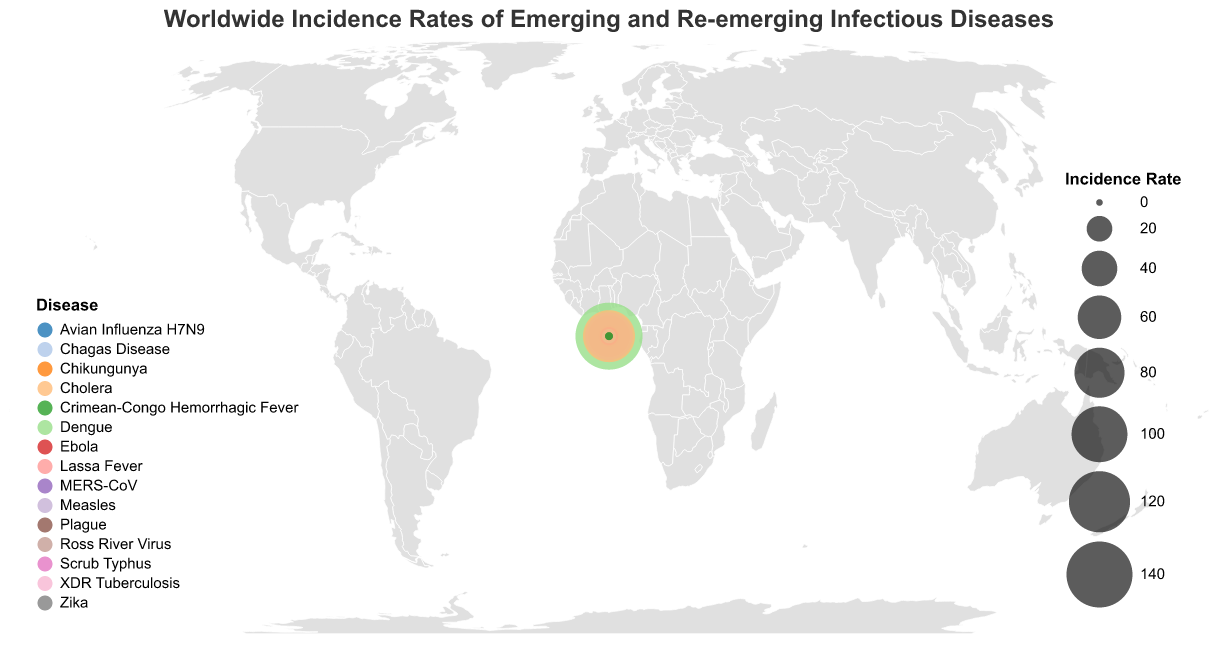What is the title of the figure? The title can be found directly at the top of the figure. It reads "Worldwide Incidence Rates of Emerging and Re-emerging Infectious Diseases."
Answer: Worldwide Incidence Rates of Emerging and Re-emerging Infectious Diseases Which country has the highest incidence rate of an infectious disease? To determine which country has the highest incidence rate, look at the size of the circles in the figure and identify the largest one. The largest circle corresponds to Brazil with Dengue.
Answer: Brazil What is the incidence rate for Cholera in Yemen? To find this, locate Yemen on the map and refer to the tooltip when hovering over the corresponding circle. The tooltip shows the incidence rate for Cholera as 86.3.
Answer: 86.3 How many different diseases are represented in the figure? Disease categories are indicated by different colors on the map. Counting the unique colors and referencing the legend confirms there are 15 different diseases.
Answer: 15 Compare the incidence rate of Measles in the Philippines to the incidence rate of Ross River Virus in Australia. Which is higher? Check the incidence rates for both countries by identifying their circles and referencing the tooltip. Measles in the Philippines is 73.1, while Ross River Virus in Australia is 54.6. Therefore, Measles has a higher incidence rate.
Answer: Measles What's the average incidence rate of Ebola across all countries? There is only one country with Ebola in this dataset, the Democratic Republic of Congo, with an incidence rate of 2.7. Since there is only one data point, the average is the value itself.
Answer: 2.7 Which continent has the most countries represented in the dataset? By visually surveying the map and counting countries in each continent, it can be seen that Africa has the highest number of countries: Democratic Republic of Congo, Nigeria, South Africa, Madagascar, and Yemen.
Answer: Africa What is the difference in incidence rates between Lassa Fever in Nigeria and XDR Tuberculosis in South Africa? Identify the incidence rates using tooltips: Lassa Fever is 3.9 in Nigeria, and XDR Tuberculosis is 1.8 in South Africa. The difference is 3.9 - 1.8 = 2.1.
Answer: 2.1 Which disease has the lowest incidence rate, and in which country does it occur? From the plot, find the smallest circle indicating the lowest incidence rate. The smallest rate is Avian Influenza H7N9 in China with an incidence rate of 0.1.
Answer: Avian Influenza H7N9, China List the names of the emerging or re-emerging infectious diseases with incidence rates below 1.0. Examine the circles on the plot and reference the tooltips for incidence rates: Zika (United States, 0.2), Avian Influenza H7N9 (China, 0.1), MERS-CoV (Saudi Arabia, 0.3), Plague (Madagascar, 0.5), Crimean-Congo Hemorrhagic Fever (Pakistan, 0.7).
Answer: Zika, Avian Influenza H7N9, MERS-CoV, Plague, Crimean-Congo Hemorrhagic Fever 